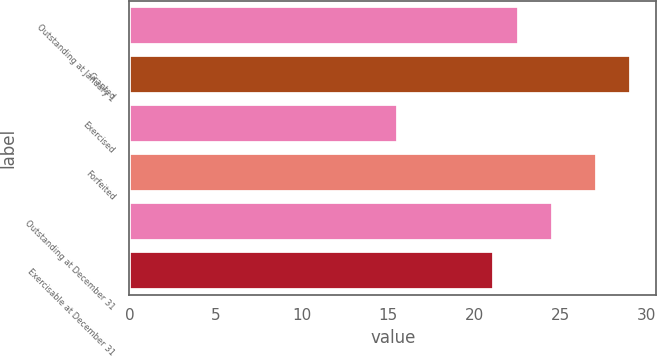Convert chart to OTSL. <chart><loc_0><loc_0><loc_500><loc_500><bar_chart><fcel>Outstanding at January 1<fcel>Granted<fcel>Exercised<fcel>Forfeited<fcel>Outstanding at December 31<fcel>Exercisable at December 31<nl><fcel>22.63<fcel>29.11<fcel>15.56<fcel>27.13<fcel>24.58<fcel>21.18<nl></chart> 